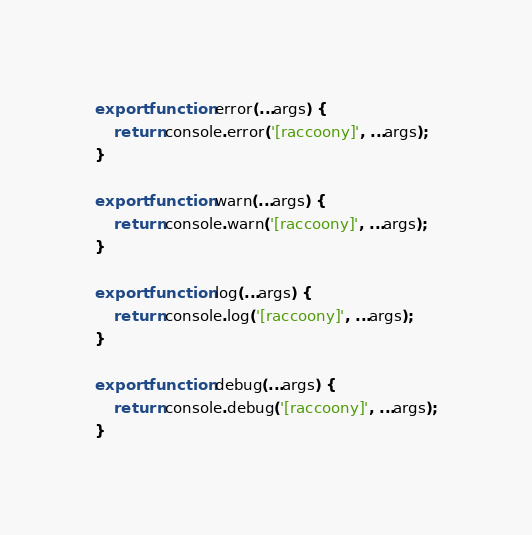Convert code to text. <code><loc_0><loc_0><loc_500><loc_500><_TypeScript_>export function error(...args) {
    return console.error('[raccoony]', ...args);
}

export function warn(...args) {
    return console.warn('[raccoony]', ...args);
}

export function log(...args) {
    return console.log('[raccoony]', ...args);
}

export function debug(...args) {
    return console.debug('[raccoony]', ...args);
}</code> 